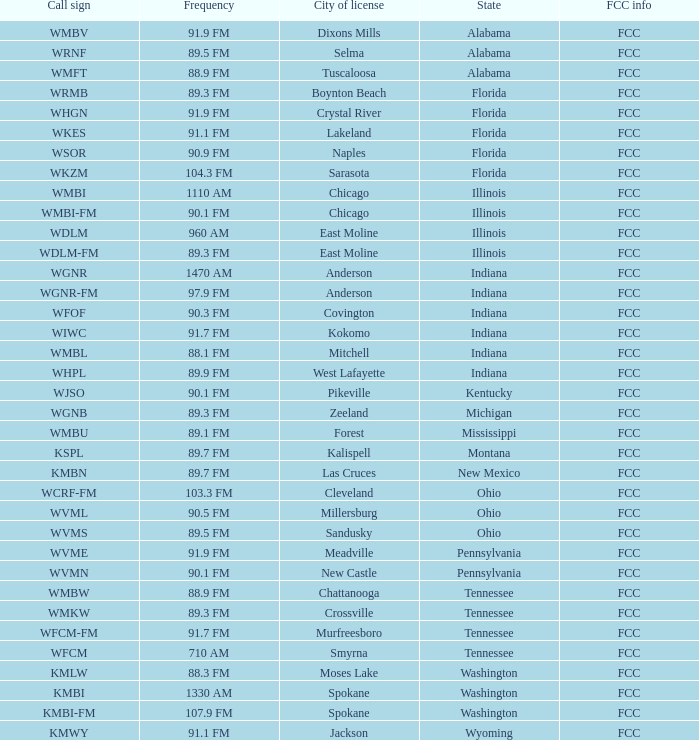What state is the radio station in that has a frequency of 90.1 FM and a city license in New Castle? Pennsylvania. Would you mind parsing the complete table? {'header': ['Call sign', 'Frequency', 'City of license', 'State', 'FCC info'], 'rows': [['WMBV', '91.9 FM', 'Dixons Mills', 'Alabama', 'FCC'], ['WRNF', '89.5 FM', 'Selma', 'Alabama', 'FCC'], ['WMFT', '88.9 FM', 'Tuscaloosa', 'Alabama', 'FCC'], ['WRMB', '89.3 FM', 'Boynton Beach', 'Florida', 'FCC'], ['WHGN', '91.9 FM', 'Crystal River', 'Florida', 'FCC'], ['WKES', '91.1 FM', 'Lakeland', 'Florida', 'FCC'], ['WSOR', '90.9 FM', 'Naples', 'Florida', 'FCC'], ['WKZM', '104.3 FM', 'Sarasota', 'Florida', 'FCC'], ['WMBI', '1110 AM', 'Chicago', 'Illinois', 'FCC'], ['WMBI-FM', '90.1 FM', 'Chicago', 'Illinois', 'FCC'], ['WDLM', '960 AM', 'East Moline', 'Illinois', 'FCC'], ['WDLM-FM', '89.3 FM', 'East Moline', 'Illinois', 'FCC'], ['WGNR', '1470 AM', 'Anderson', 'Indiana', 'FCC'], ['WGNR-FM', '97.9 FM', 'Anderson', 'Indiana', 'FCC'], ['WFOF', '90.3 FM', 'Covington', 'Indiana', 'FCC'], ['WIWC', '91.7 FM', 'Kokomo', 'Indiana', 'FCC'], ['WMBL', '88.1 FM', 'Mitchell', 'Indiana', 'FCC'], ['WHPL', '89.9 FM', 'West Lafayette', 'Indiana', 'FCC'], ['WJSO', '90.1 FM', 'Pikeville', 'Kentucky', 'FCC'], ['WGNB', '89.3 FM', 'Zeeland', 'Michigan', 'FCC'], ['WMBU', '89.1 FM', 'Forest', 'Mississippi', 'FCC'], ['KSPL', '89.7 FM', 'Kalispell', 'Montana', 'FCC'], ['KMBN', '89.7 FM', 'Las Cruces', 'New Mexico', 'FCC'], ['WCRF-FM', '103.3 FM', 'Cleveland', 'Ohio', 'FCC'], ['WVML', '90.5 FM', 'Millersburg', 'Ohio', 'FCC'], ['WVMS', '89.5 FM', 'Sandusky', 'Ohio', 'FCC'], ['WVME', '91.9 FM', 'Meadville', 'Pennsylvania', 'FCC'], ['WVMN', '90.1 FM', 'New Castle', 'Pennsylvania', 'FCC'], ['WMBW', '88.9 FM', 'Chattanooga', 'Tennessee', 'FCC'], ['WMKW', '89.3 FM', 'Crossville', 'Tennessee', 'FCC'], ['WFCM-FM', '91.7 FM', 'Murfreesboro', 'Tennessee', 'FCC'], ['WFCM', '710 AM', 'Smyrna', 'Tennessee', 'FCC'], ['KMLW', '88.3 FM', 'Moses Lake', 'Washington', 'FCC'], ['KMBI', '1330 AM', 'Spokane', 'Washington', 'FCC'], ['KMBI-FM', '107.9 FM', 'Spokane', 'Washington', 'FCC'], ['KMWY', '91.1 FM', 'Jackson', 'Wyoming', 'FCC']]} 